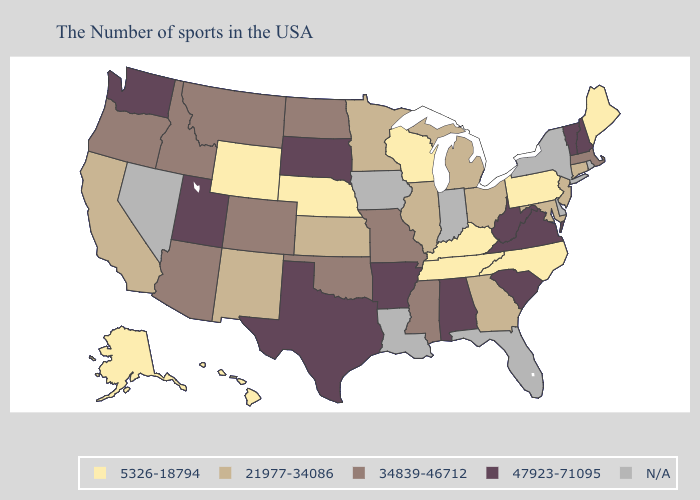Does Kentucky have the lowest value in the South?
Write a very short answer. Yes. Among the states that border Arkansas , which have the lowest value?
Give a very brief answer. Tennessee. Which states have the highest value in the USA?
Short answer required. New Hampshire, Vermont, Virginia, South Carolina, West Virginia, Alabama, Arkansas, Texas, South Dakota, Utah, Washington. Which states have the lowest value in the USA?
Be succinct. Maine, Pennsylvania, North Carolina, Kentucky, Tennessee, Wisconsin, Nebraska, Wyoming, Alaska, Hawaii. What is the value of New Hampshire?
Write a very short answer. 47923-71095. Is the legend a continuous bar?
Write a very short answer. No. What is the value of Kansas?
Be succinct. 21977-34086. Is the legend a continuous bar?
Short answer required. No. Among the states that border Rhode Island , does Connecticut have the lowest value?
Concise answer only. Yes. Name the states that have a value in the range 21977-34086?
Answer briefly. Connecticut, New Jersey, Maryland, Ohio, Georgia, Michigan, Illinois, Minnesota, Kansas, New Mexico, California. Is the legend a continuous bar?
Be succinct. No. What is the highest value in the Northeast ?
Concise answer only. 47923-71095. What is the value of Missouri?
Keep it brief. 34839-46712. 